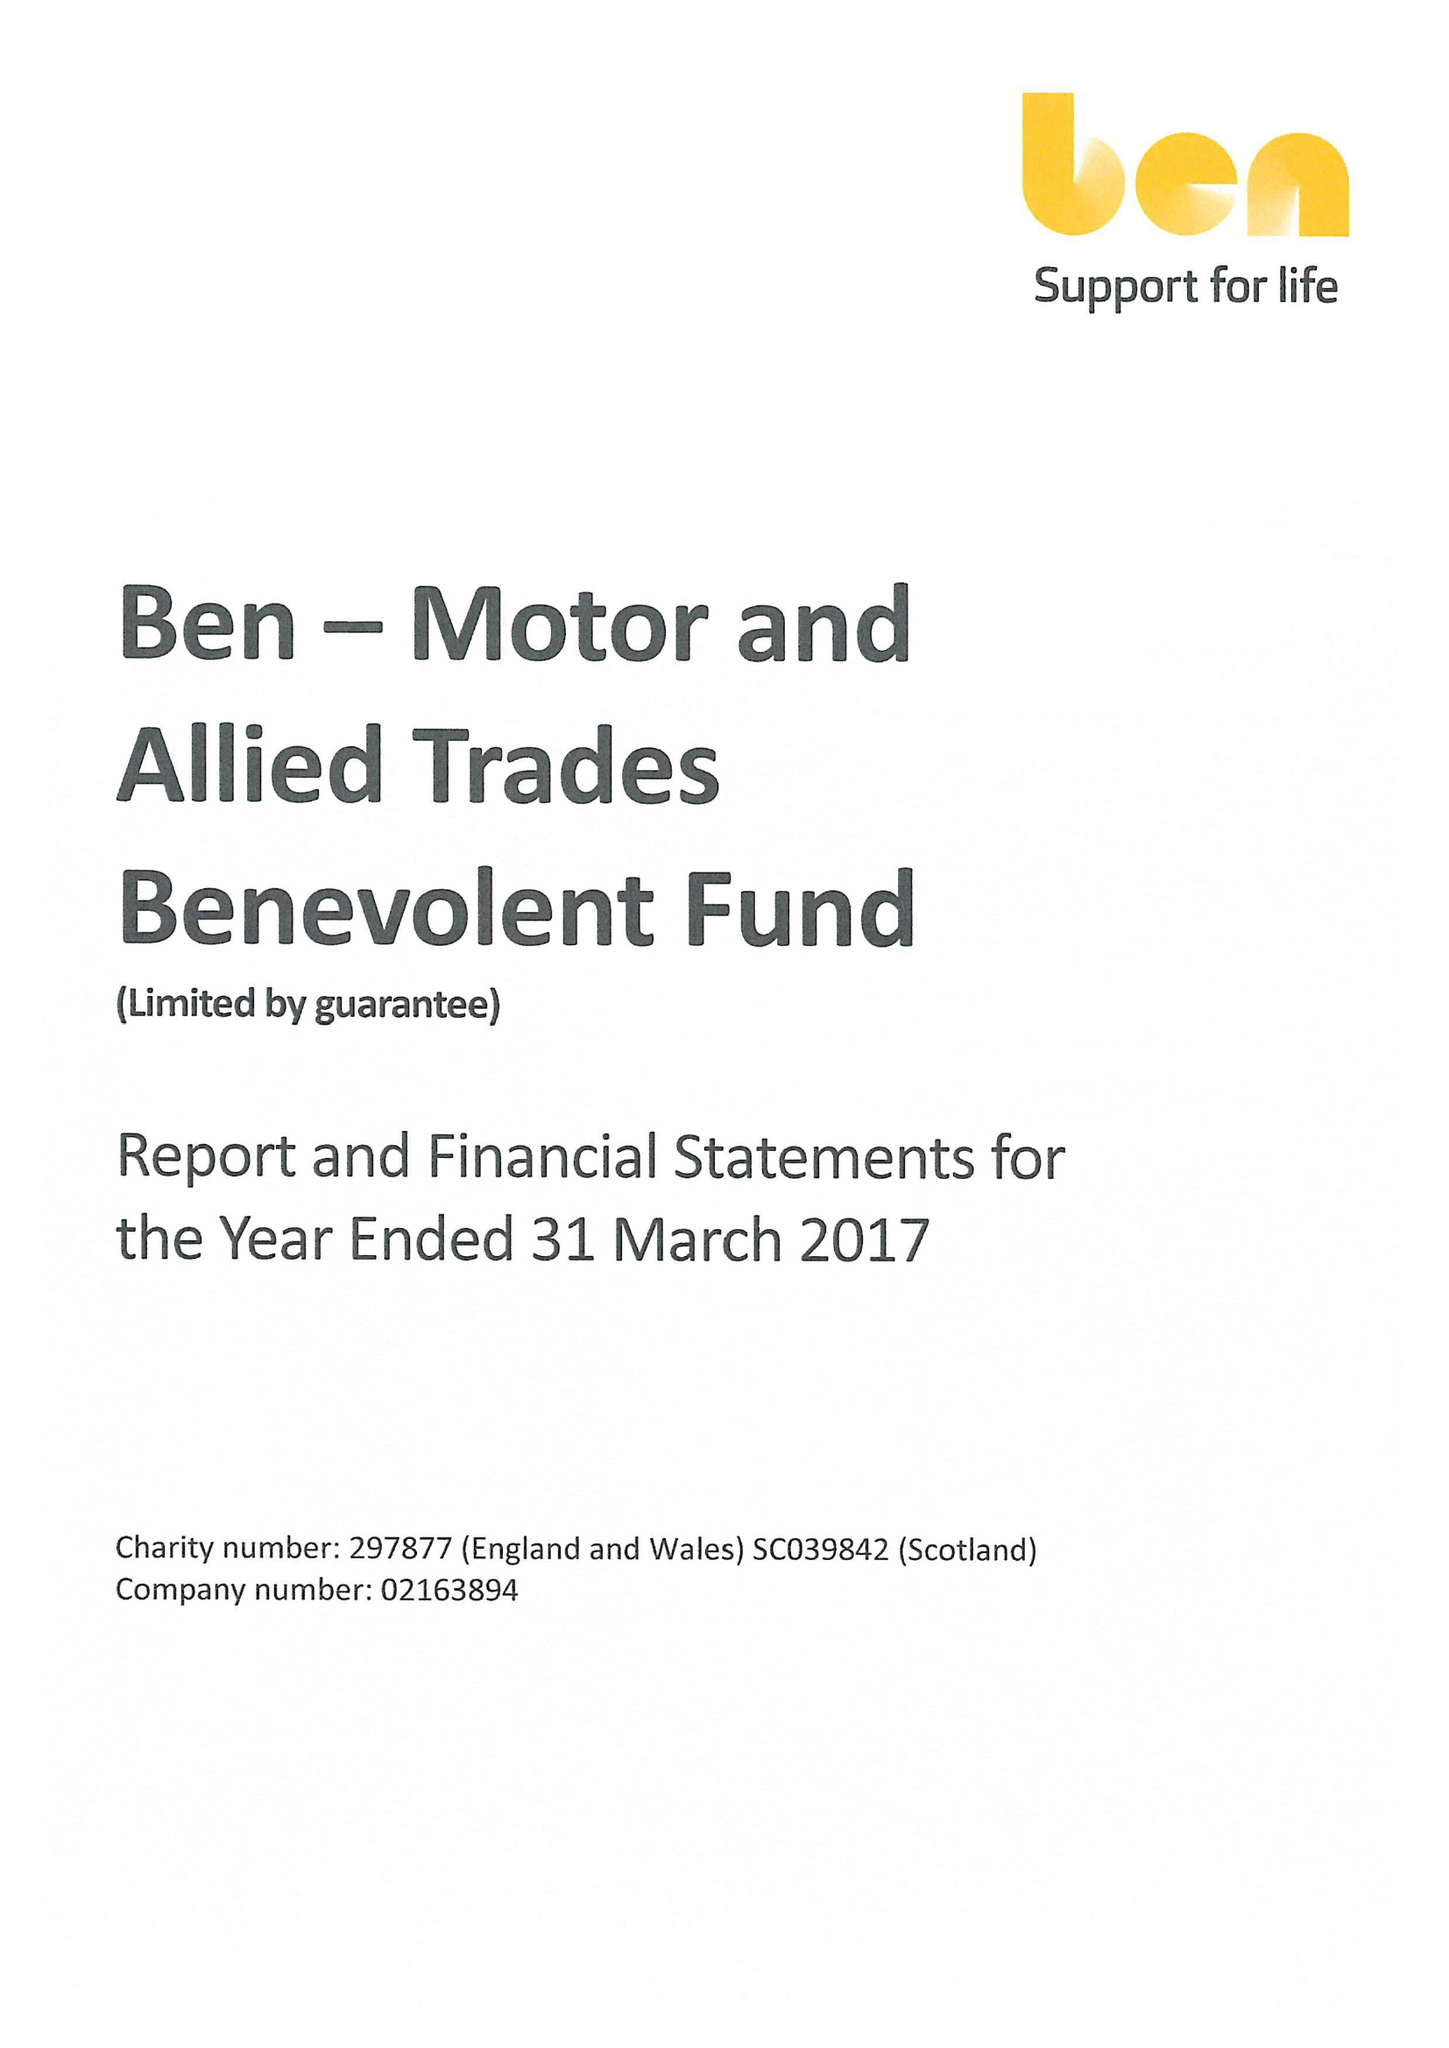What is the value for the address__postcode?
Answer the question using a single word or phrase. SL5 0FG 